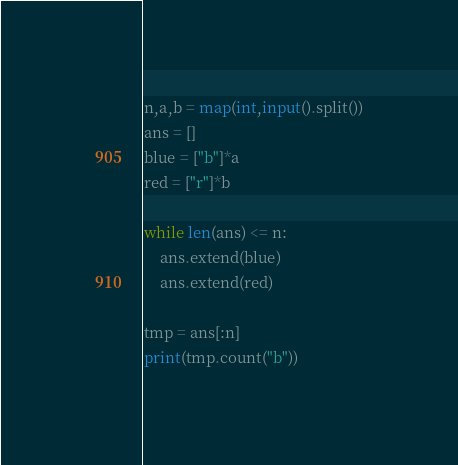Convert code to text. <code><loc_0><loc_0><loc_500><loc_500><_Python_>n,a,b = map(int,input().split())
ans = []
blue = ["b"]*a
red = ["r"]*b

while len(ans) <= n:
	ans.extend(blue)
	ans.extend(red)
	
tmp = ans[:n]
print(tmp.count("b"))
</code> 